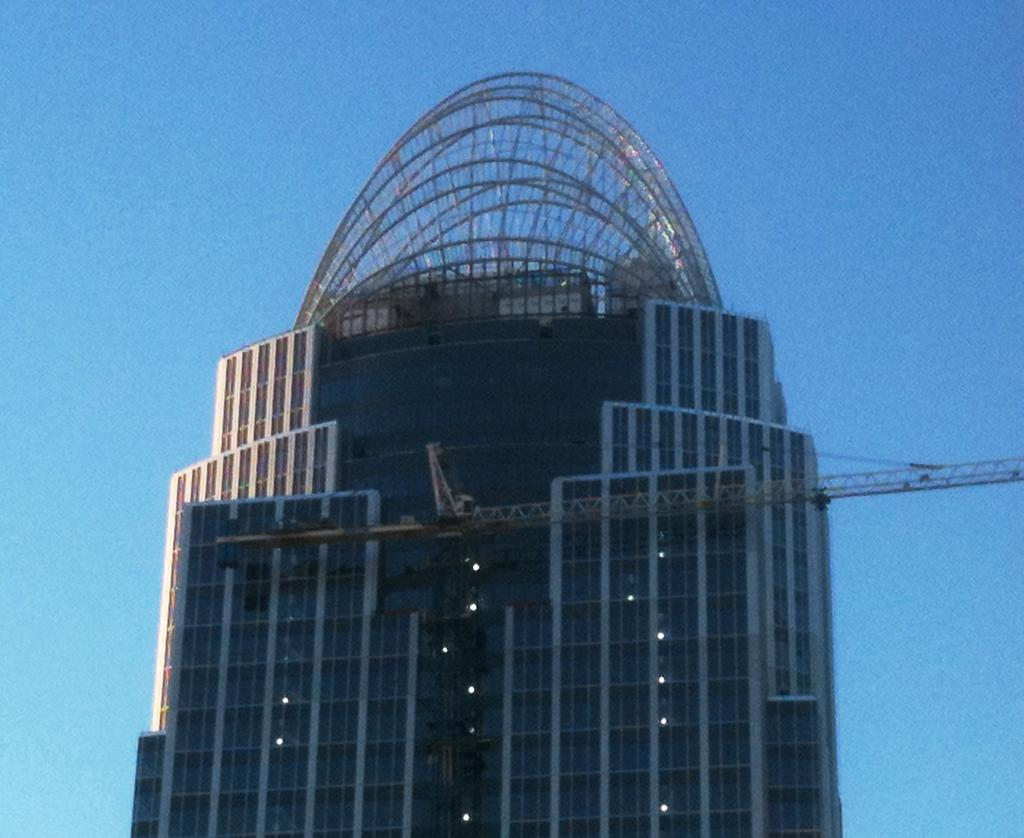What type of structure is visible in the image? There is a building with windows in the image. What is located in front of the building? There is an object in front of the building. What can be seen in the sky in the background of the image? There are clouds in the sky in the background of the image. What type of silk is being used to cover the windows of the building in the image? There is no mention of silk or any window covering in the image. 